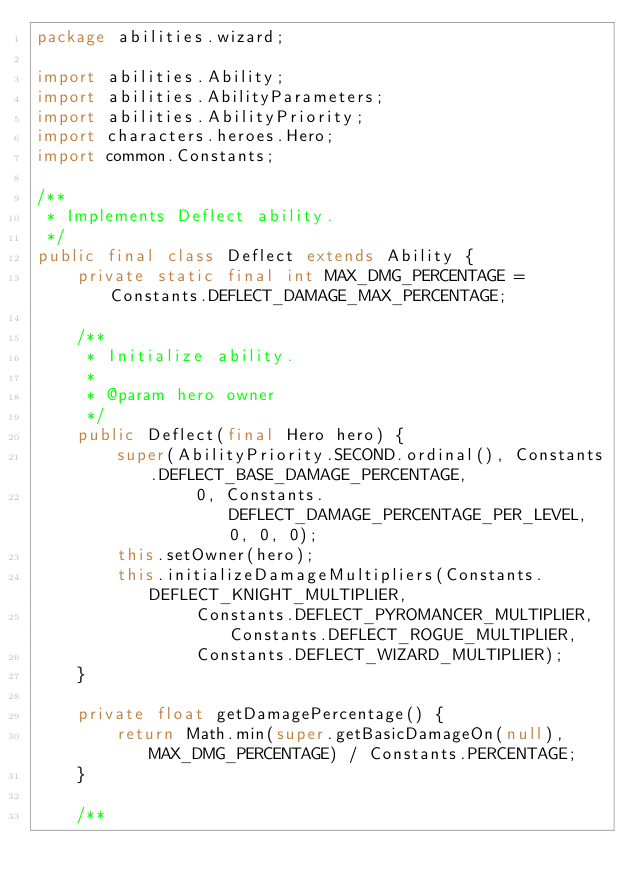<code> <loc_0><loc_0><loc_500><loc_500><_Java_>package abilities.wizard;

import abilities.Ability;
import abilities.AbilityParameters;
import abilities.AbilityPriority;
import characters.heroes.Hero;
import common.Constants;

/**
 * Implements Deflect ability.
 */
public final class Deflect extends Ability {
    private static final int MAX_DMG_PERCENTAGE = Constants.DEFLECT_DAMAGE_MAX_PERCENTAGE;

    /**
     * Initialize ability.
     *
     * @param hero owner
     */
    public Deflect(final Hero hero) {
        super(AbilityPriority.SECOND.ordinal(), Constants.DEFLECT_BASE_DAMAGE_PERCENTAGE,
                0, Constants.DEFLECT_DAMAGE_PERCENTAGE_PER_LEVEL, 0, 0, 0);
        this.setOwner(hero);
        this.initializeDamageMultipliers(Constants.DEFLECT_KNIGHT_MULTIPLIER,
                Constants.DEFLECT_PYROMANCER_MULTIPLIER, Constants.DEFLECT_ROGUE_MULTIPLIER,
                Constants.DEFLECT_WIZARD_MULTIPLIER);
    }

    private float getDamagePercentage() {
        return Math.min(super.getBasicDamageOn(null), MAX_DMG_PERCENTAGE) / Constants.PERCENTAGE;
    }

    /**</code> 